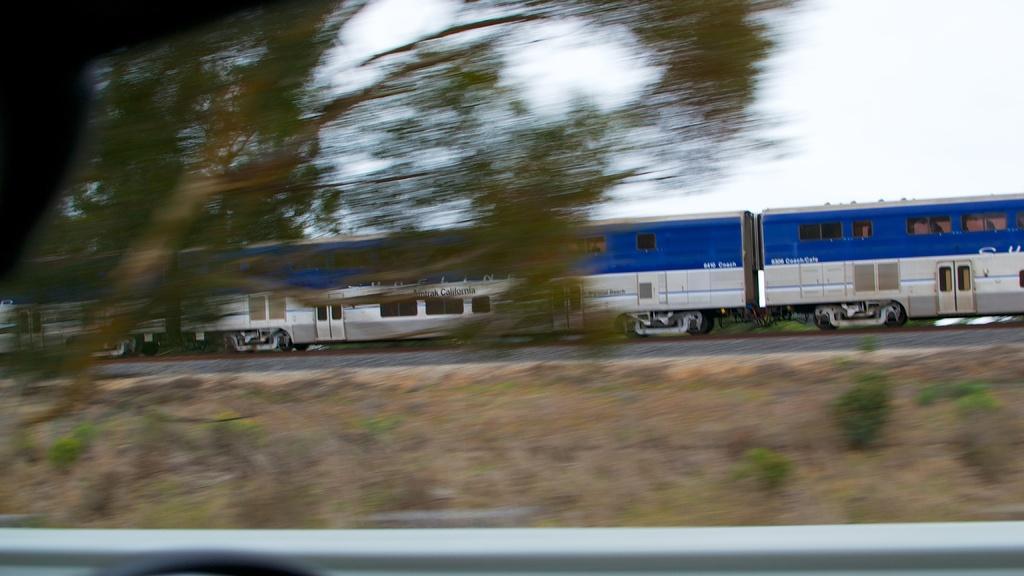How would you summarize this image in a sentence or two? In the picture I can see a train on a railway track. On the left side I can see a tree. In the background I can see the sky. 